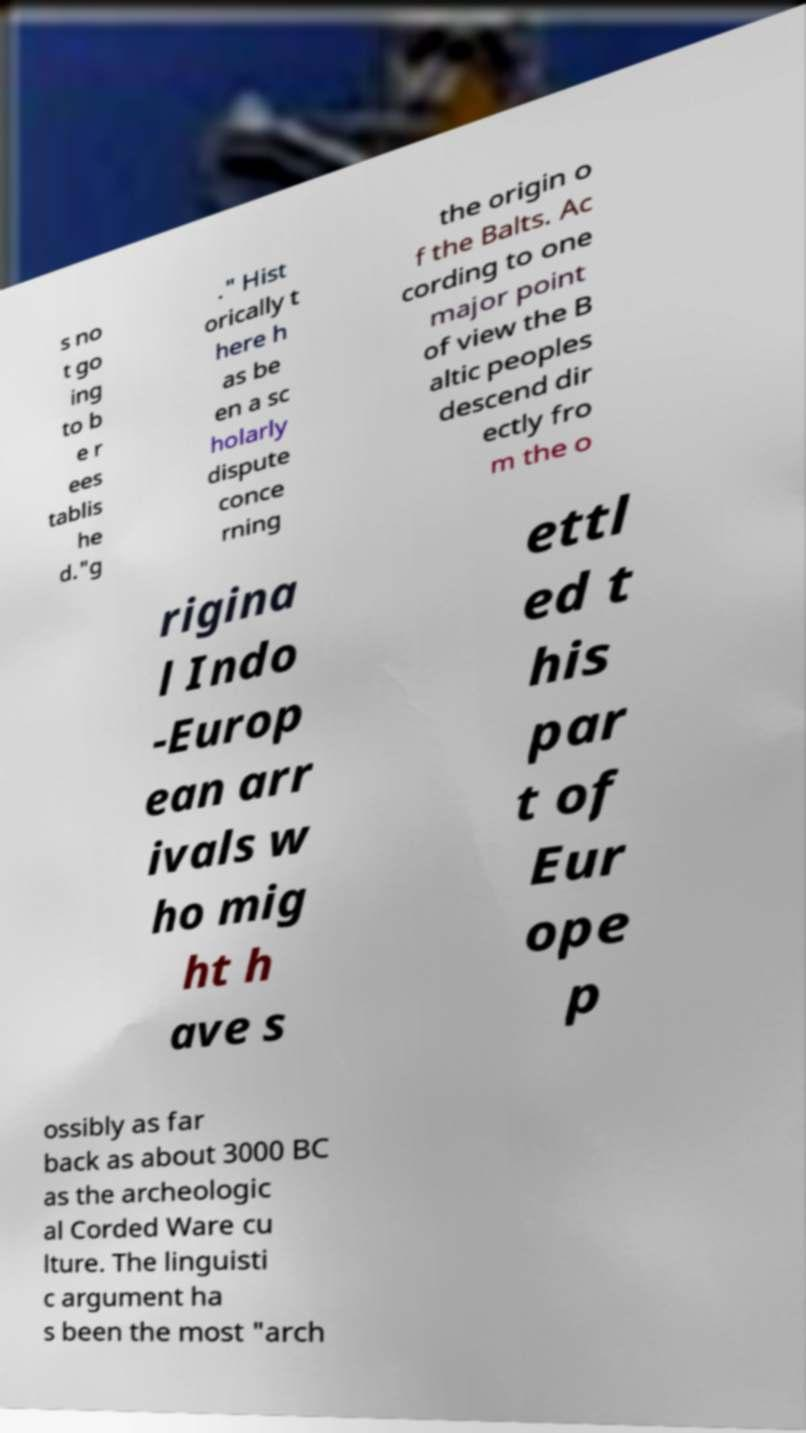Please identify and transcribe the text found in this image. s no t go ing to b e r ees tablis he d."g ." Hist orically t here h as be en a sc holarly dispute conce rning the origin o f the Balts. Ac cording to one major point of view the B altic peoples descend dir ectly fro m the o rigina l Indo -Europ ean arr ivals w ho mig ht h ave s ettl ed t his par t of Eur ope p ossibly as far back as about 3000 BC as the archeologic al Corded Ware cu lture. The linguisti c argument ha s been the most "arch 